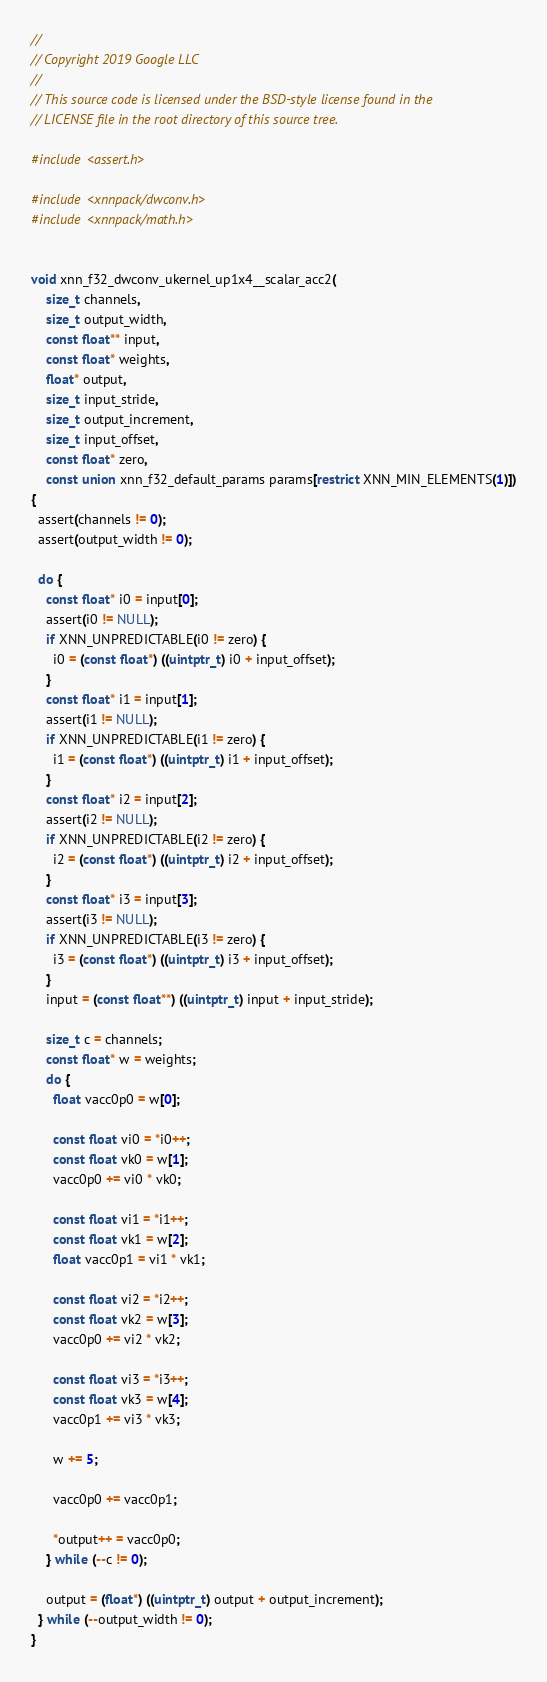<code> <loc_0><loc_0><loc_500><loc_500><_C_>//
// Copyright 2019 Google LLC
//
// This source code is licensed under the BSD-style license found in the
// LICENSE file in the root directory of this source tree.

#include <assert.h>

#include <xnnpack/dwconv.h>
#include <xnnpack/math.h>


void xnn_f32_dwconv_ukernel_up1x4__scalar_acc2(
    size_t channels,
    size_t output_width,
    const float** input,
    const float* weights,
    float* output,
    size_t input_stride,
    size_t output_increment,
    size_t input_offset,
    const float* zero,
    const union xnn_f32_default_params params[restrict XNN_MIN_ELEMENTS(1)])
{
  assert(channels != 0);
  assert(output_width != 0);

  do {
    const float* i0 = input[0];
    assert(i0 != NULL);
    if XNN_UNPREDICTABLE(i0 != zero) {
      i0 = (const float*) ((uintptr_t) i0 + input_offset);
    }
    const float* i1 = input[1];
    assert(i1 != NULL);
    if XNN_UNPREDICTABLE(i1 != zero) {
      i1 = (const float*) ((uintptr_t) i1 + input_offset);
    }
    const float* i2 = input[2];
    assert(i2 != NULL);
    if XNN_UNPREDICTABLE(i2 != zero) {
      i2 = (const float*) ((uintptr_t) i2 + input_offset);
    }
    const float* i3 = input[3];
    assert(i3 != NULL);
    if XNN_UNPREDICTABLE(i3 != zero) {
      i3 = (const float*) ((uintptr_t) i3 + input_offset);
    }
    input = (const float**) ((uintptr_t) input + input_stride);

    size_t c = channels;
    const float* w = weights;
    do {
      float vacc0p0 = w[0];

      const float vi0 = *i0++;
      const float vk0 = w[1];
      vacc0p0 += vi0 * vk0;

      const float vi1 = *i1++;
      const float vk1 = w[2];
      float vacc0p1 = vi1 * vk1;

      const float vi2 = *i2++;
      const float vk2 = w[3];
      vacc0p0 += vi2 * vk2;

      const float vi3 = *i3++;
      const float vk3 = w[4];
      vacc0p1 += vi3 * vk3;

      w += 5;

      vacc0p0 += vacc0p1;

      *output++ = vacc0p0;
    } while (--c != 0);

    output = (float*) ((uintptr_t) output + output_increment);
  } while (--output_width != 0);
}
</code> 